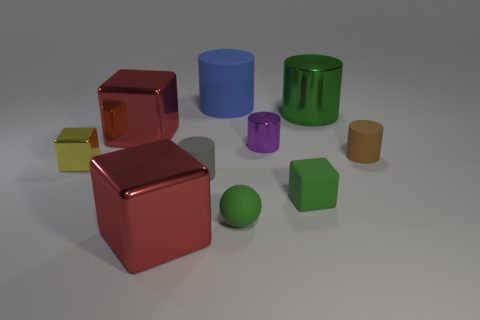Are there any blue objects that have the same size as the ball?
Your answer should be compact. No. There is a large cylinder that is the same material as the sphere; what color is it?
Your answer should be very brief. Blue. Are there fewer yellow things than purple matte blocks?
Give a very brief answer. No. There is a thing that is both behind the tiny shiny cylinder and on the right side of the small green sphere; what is its material?
Provide a short and direct response. Metal. Is there a cube on the right side of the tiny brown object on the right side of the tiny green ball?
Keep it short and to the point. No. What number of tiny cylinders are the same color as the rubber ball?
Make the answer very short. 0. What is the material of the cylinder that is the same color as the small matte block?
Your response must be concise. Metal. Does the tiny gray cylinder have the same material as the tiny ball?
Give a very brief answer. Yes. There is a tiny green block; are there any large rubber cylinders on the right side of it?
Ensure brevity in your answer.  No. There is a red cube that is behind the green rubber object that is left of the green block; what is it made of?
Keep it short and to the point. Metal. 